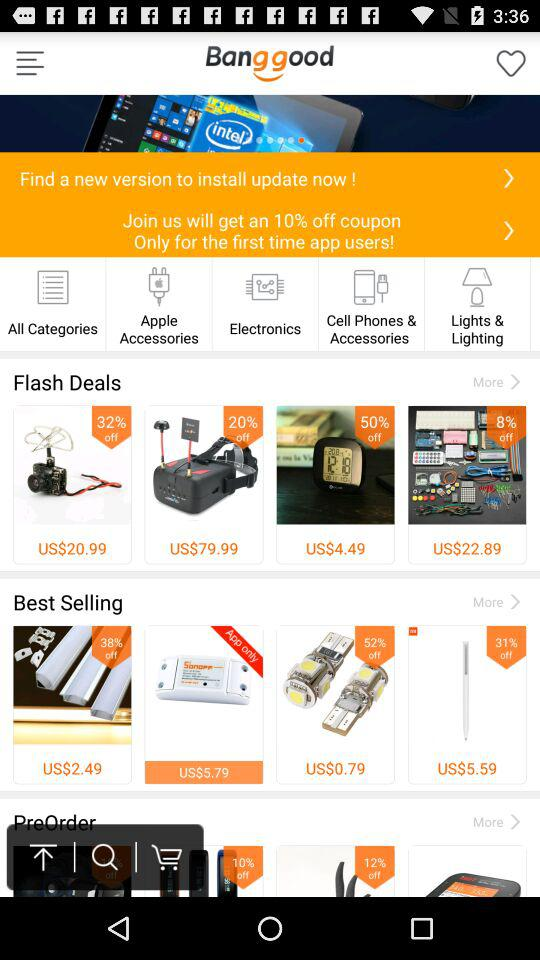What is the cost of the item having a 50% discount? The cost is $4.49 USD. 